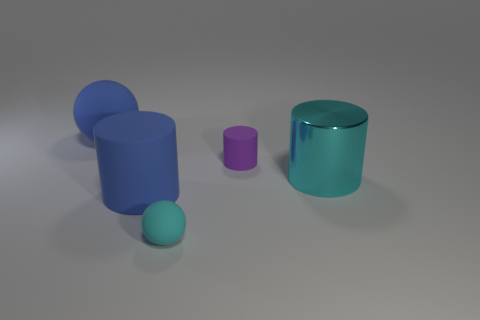Is the color of the shiny cylinder the same as the tiny ball?
Give a very brief answer. Yes. What number of objects are large shiny cylinders or things that are behind the cyan metal cylinder?
Keep it short and to the point. 3. What is the color of the large object behind the large cyan thing?
Offer a terse response. Blue. What shape is the metallic object?
Ensure brevity in your answer.  Cylinder. There is a tiny thing that is to the left of the tiny thing that is right of the small cyan matte object; what is it made of?
Offer a terse response. Rubber. How many other objects are the same material as the big cyan cylinder?
Make the answer very short. 0. There is a cyan object that is the same size as the blue sphere; what material is it?
Provide a succinct answer. Metal. Are there more small rubber balls that are on the left side of the cyan shiny object than small cyan balls that are behind the tiny rubber cylinder?
Make the answer very short. Yes. Are there any other blue things that have the same shape as the large metallic object?
Provide a succinct answer. Yes. There is a cyan rubber thing that is the same size as the purple matte cylinder; what shape is it?
Give a very brief answer. Sphere. 